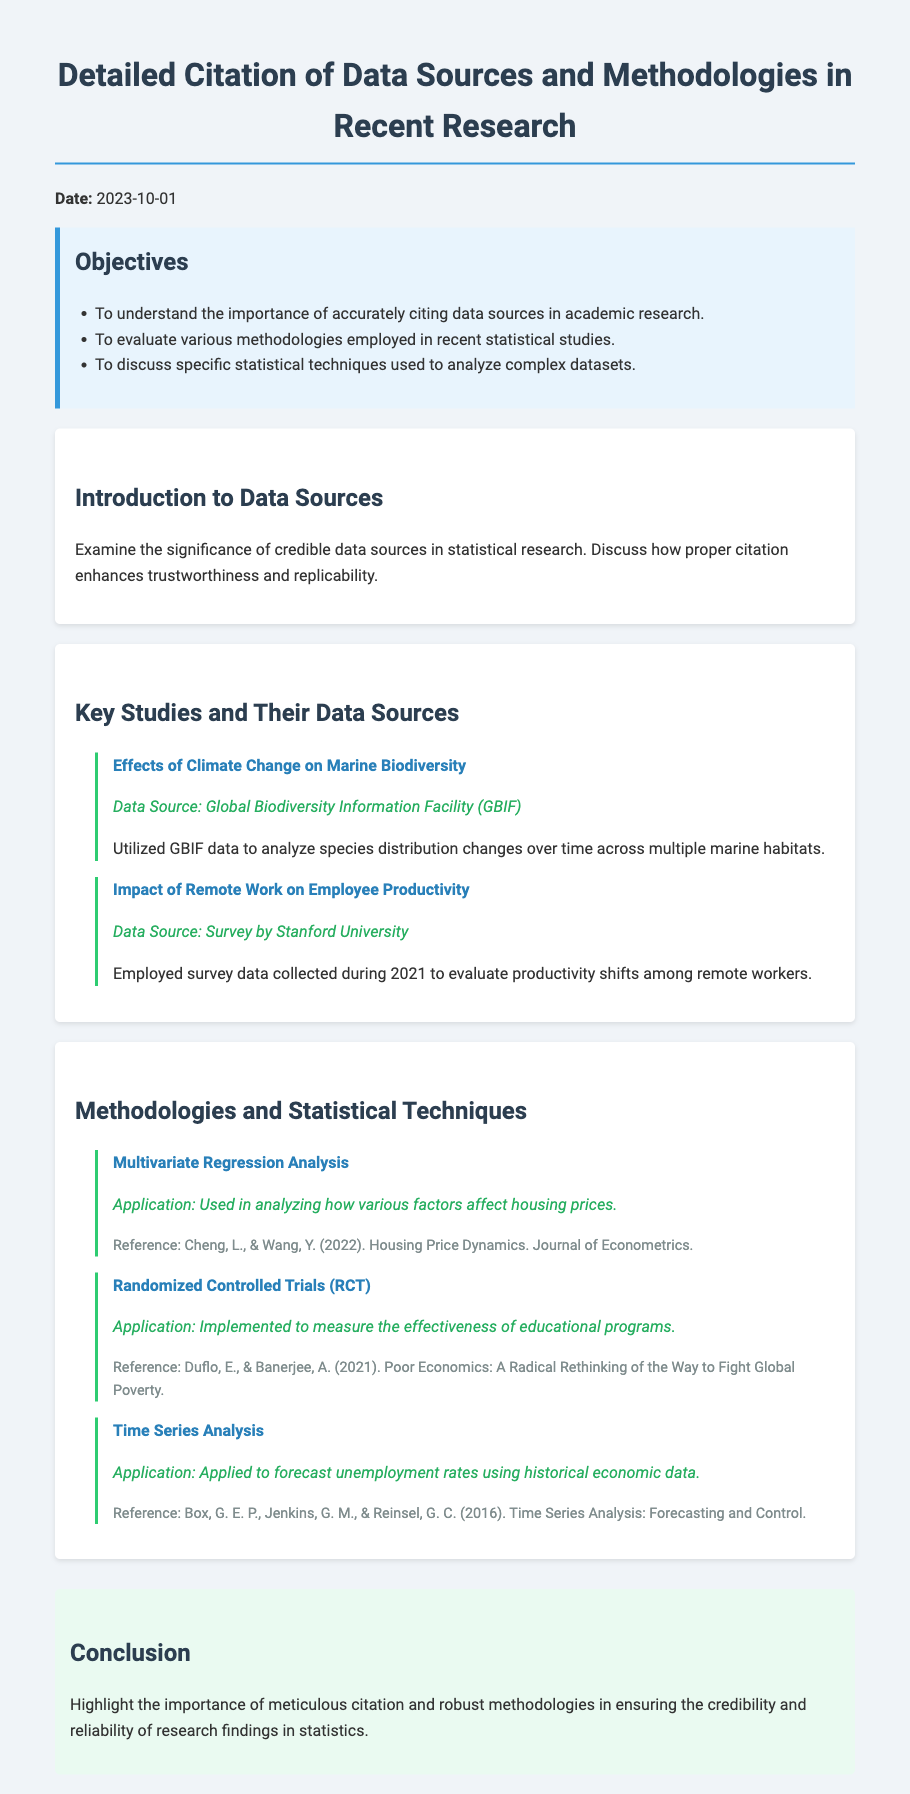what is the date of the document? The date mentioned in the document indicates when it was created or relevant, which is provided clearly at the beginning.
Answer: 2023-10-01 what is the title of the study that examines the effects of climate change? This question refers to the specific study listed in the document focusing on climate change impacts, which is explicitly named in the key studies section.
Answer: Effects of Climate Change on Marine Biodiversity who conducted the survey for the study on remote work? The document cites the source of the data for the study regarding productivity in remote work, indicating the organization responsible for the survey.
Answer: Stanford University what statistical technique is used for analyzing housing prices? The document outlines different methodologies, specifically naming the statistical approach used in the context of housing pricing analysis.
Answer: Multivariate Regression Analysis what is the primary focus of the conclusion section? This question pertains to the overall message conveyed in the conclusion, clearly summarizing the main theme discussed throughout the document.
Answer: importance of meticulous citation and robust methodologies which application is associated with Randomized Controlled Trials? The application of RCTs is detailed in the methodology section, indicating its purpose within educational contexts.
Answer: measure the effectiveness of educational programs how many methodologies are discussed in the document? This question requires adding up the methodologies provided, as each is listed individually within a designated section.
Answer: three what is the reference for the Time Series Analysis methodology? The reference documents the source of the methodology discussed, which can be found in the section detailing methodologies.
Answer: Box, G. E. P., Jenkins, G. M., & Reinsel, G. C. (2016). Time Series Analysis: Forecasting and Control 